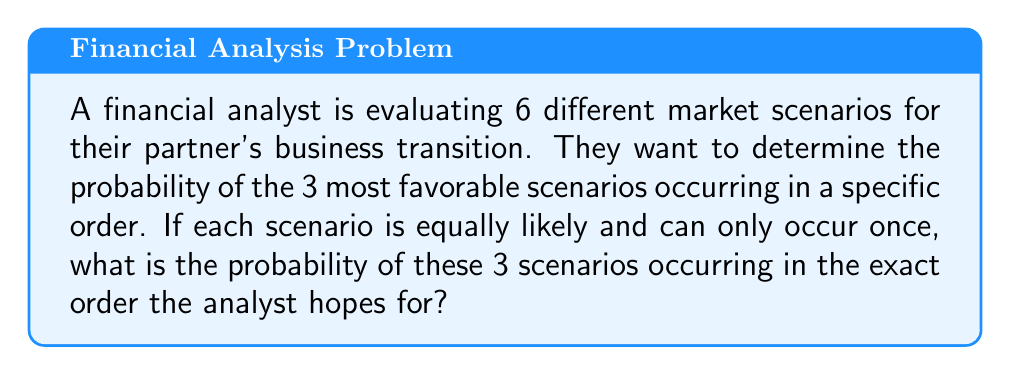What is the answer to this math problem? Let's approach this step-by-step:

1) First, we need to understand what we're calculating. We're looking for the probability of 3 specific scenarios occurring in a specific order out of 6 possible scenarios.

2) This is a permutation problem. We're selecting 3 scenarios out of 6, and the order matters.

3) The total number of possible permutations of 6 scenarios taken 3 at a time is given by the formula:

   $P(6,3) = \frac{6!}{(6-3)!} = \frac{6!}{3!} = 6 \cdot 5 \cdot 4 = 120$

4) This represents all possible ways to arrange 3 scenarios out of 6.

5) However, we're only interested in one specific arrangement of 3 specific scenarios.

6) The probability of this specific arrangement occurring is:

   $P(\text{specific arrangement}) = \frac{1}{\text{total number of possible arrangements}} = \frac{1}{120}$

7) Therefore, the probability is $\frac{1}{120}$ or approximately 0.00833 or 0.833%.
Answer: $\frac{1}{120}$ 